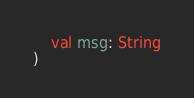<code> <loc_0><loc_0><loc_500><loc_500><_Kotlin_>    val msg: String
)
</code> 